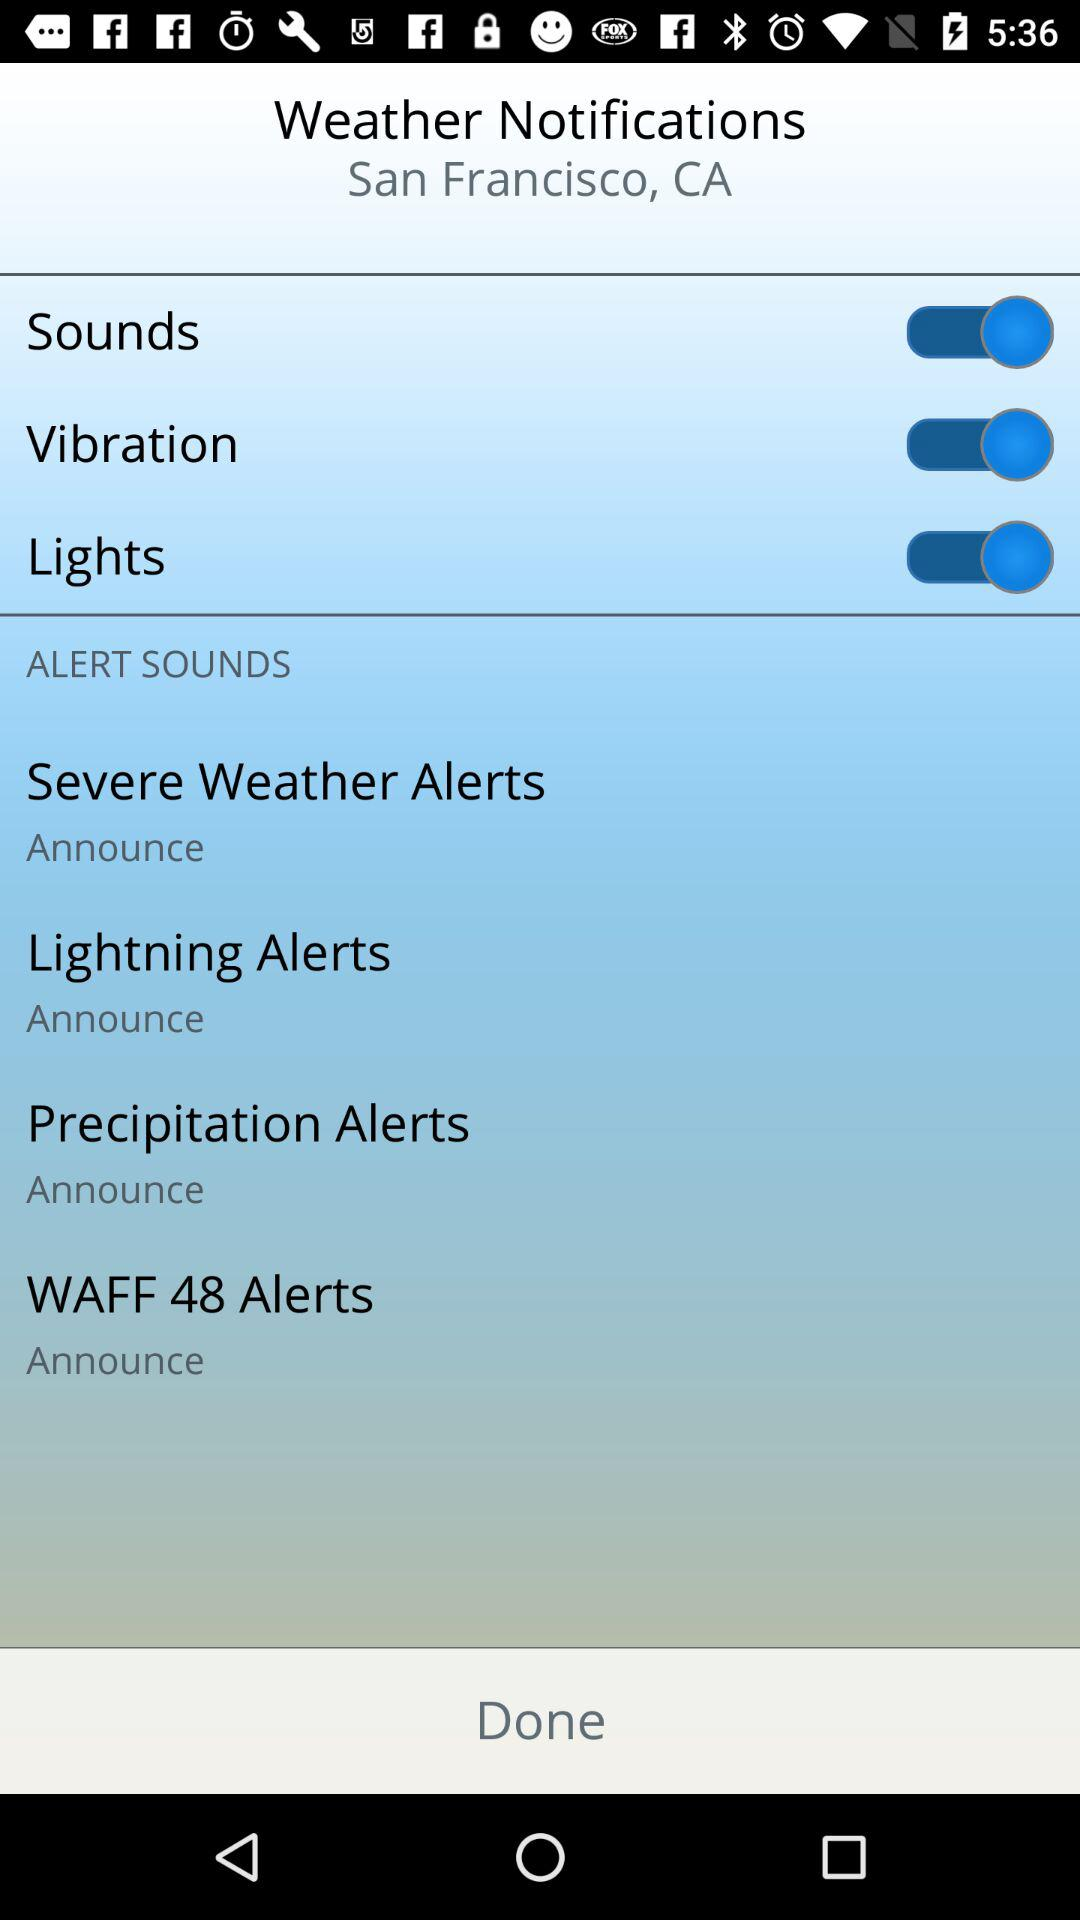What's the status of "Sounds"? The status of "Sounds" is "on". 